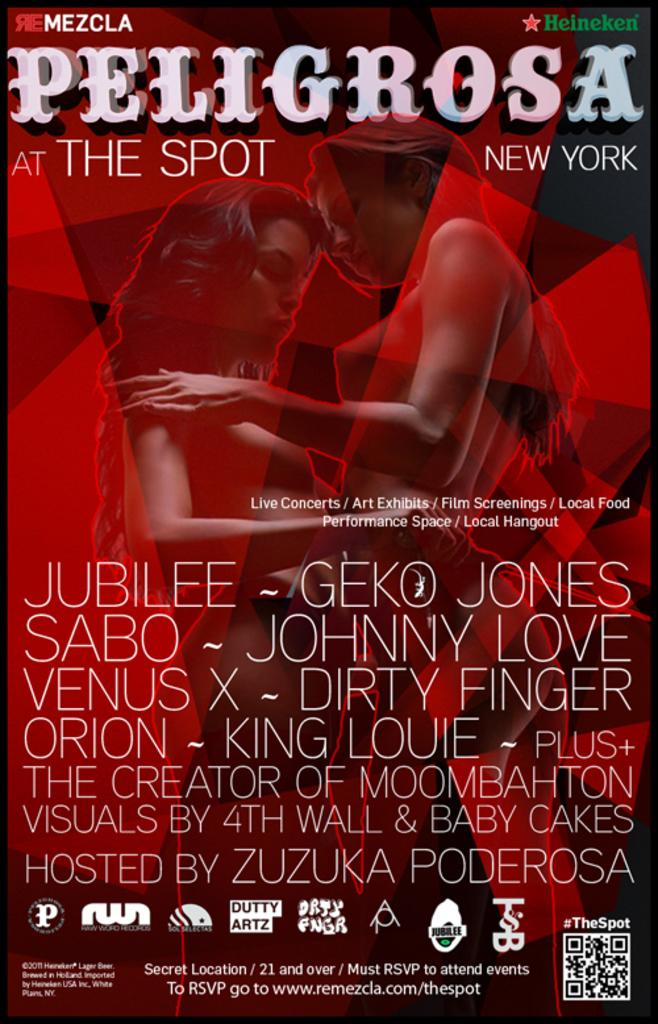What alcohol company is sponsoring this event?
Offer a terse response. Heineken. Where is the event?
Your answer should be very brief. New york. 